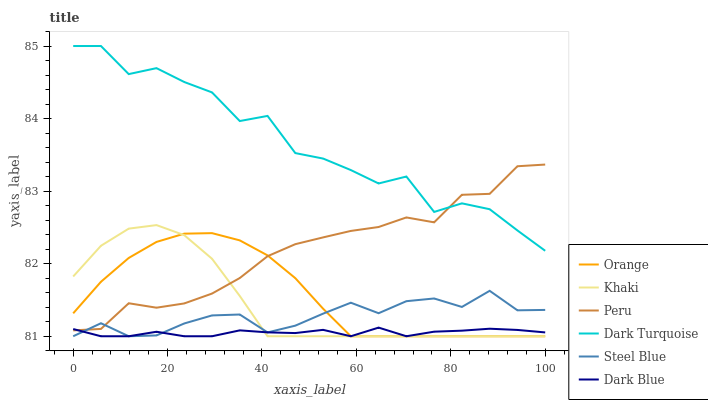Does Dark Blue have the minimum area under the curve?
Answer yes or no. Yes. Does Dark Turquoise have the maximum area under the curve?
Answer yes or no. Yes. Does Steel Blue have the minimum area under the curve?
Answer yes or no. No. Does Steel Blue have the maximum area under the curve?
Answer yes or no. No. Is Orange the smoothest?
Answer yes or no. Yes. Is Dark Turquoise the roughest?
Answer yes or no. Yes. Is Steel Blue the smoothest?
Answer yes or no. No. Is Steel Blue the roughest?
Answer yes or no. No. Does Khaki have the lowest value?
Answer yes or no. Yes. Does Dark Turquoise have the lowest value?
Answer yes or no. No. Does Dark Turquoise have the highest value?
Answer yes or no. Yes. Does Steel Blue have the highest value?
Answer yes or no. No. Is Orange less than Dark Turquoise?
Answer yes or no. Yes. Is Dark Turquoise greater than Orange?
Answer yes or no. Yes. Does Dark Blue intersect Orange?
Answer yes or no. Yes. Is Dark Blue less than Orange?
Answer yes or no. No. Is Dark Blue greater than Orange?
Answer yes or no. No. Does Orange intersect Dark Turquoise?
Answer yes or no. No. 